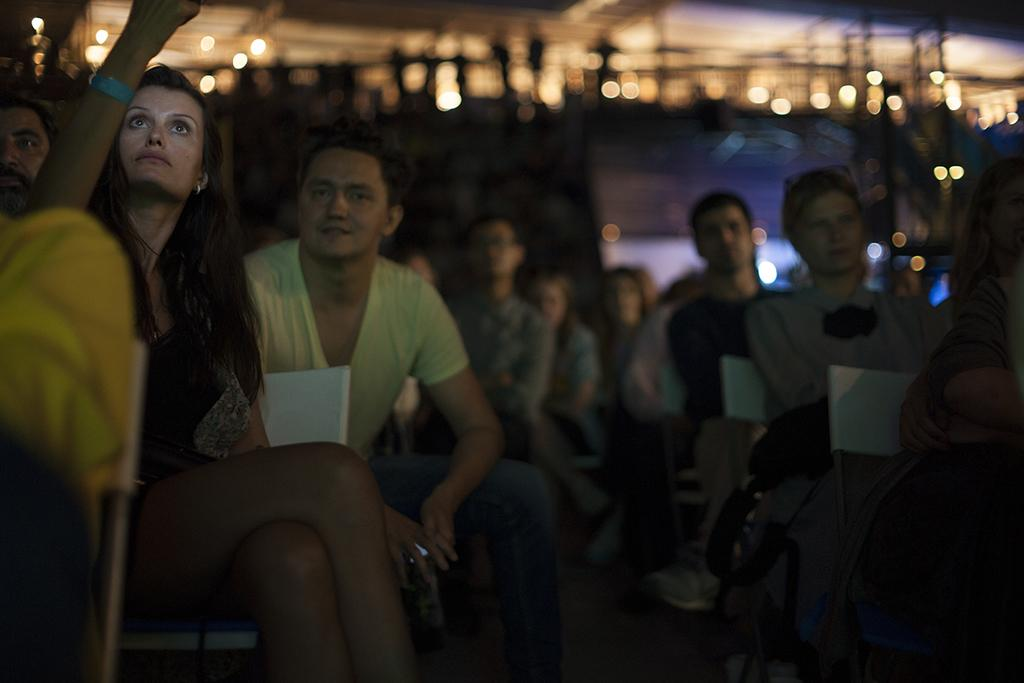What is the main subject of the image? The main subject of the image is a group of people. How are the people dressed in the image? The people are wearing different color dresses in the image. What are the people doing in the image? The people are sitting on chairs in the image. What can be seen in the background of the image? There are lights visible in the background of the image, and the background appears blurry. What type of beast can be seen in the image? There is no beast present in the image; it features a group of people sitting on chairs. What role does the mother play in the image? There is no mention of a mother or any specific roles in the image; it simply shows a group of people sitting on chairs. 